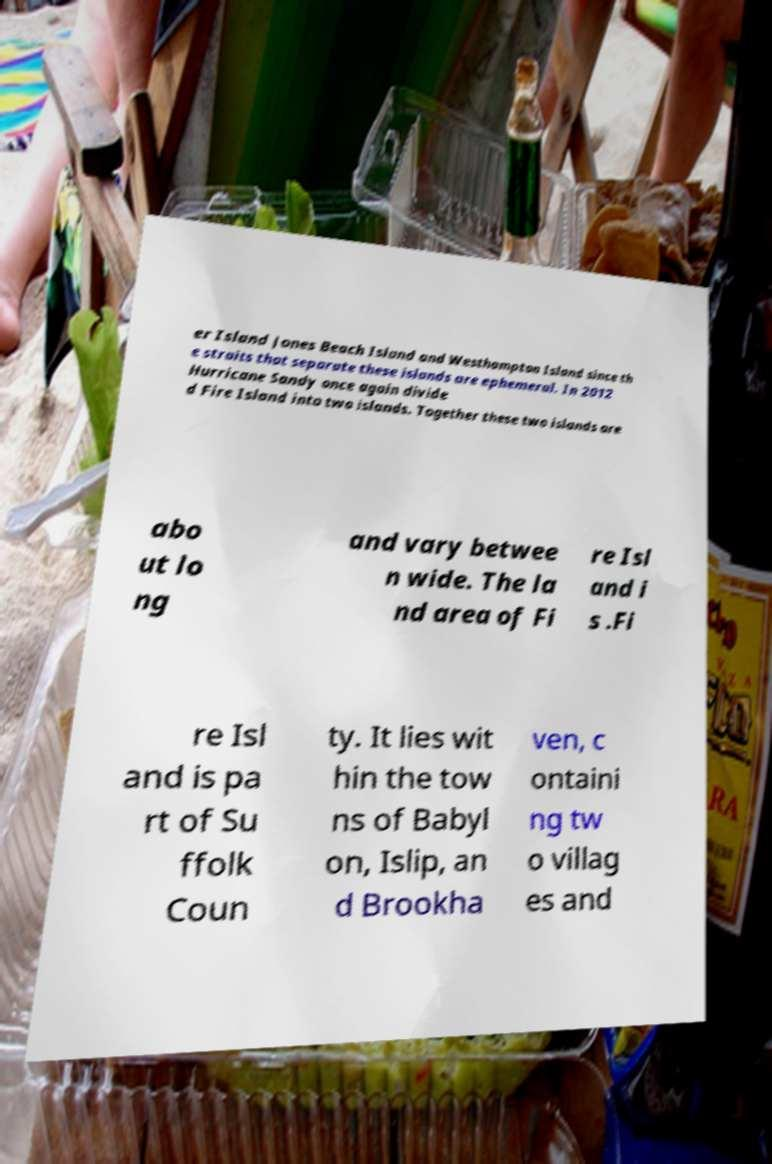Please read and relay the text visible in this image. What does it say? er Island Jones Beach Island and Westhampton Island since th e straits that separate these islands are ephemeral. In 2012 Hurricane Sandy once again divide d Fire Island into two islands. Together these two islands are abo ut lo ng and vary betwee n wide. The la nd area of Fi re Isl and i s .Fi re Isl and is pa rt of Su ffolk Coun ty. It lies wit hin the tow ns of Babyl on, Islip, an d Brookha ven, c ontaini ng tw o villag es and 